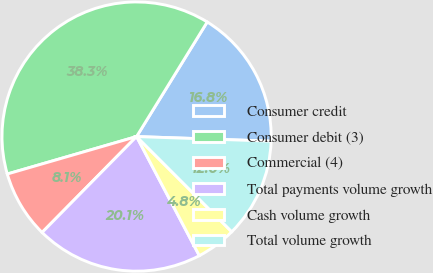Convert chart. <chart><loc_0><loc_0><loc_500><loc_500><pie_chart><fcel>Consumer credit<fcel>Consumer debit (3)<fcel>Commercial (4)<fcel>Total payments volume growth<fcel>Cash volume growth<fcel>Total volume growth<nl><fcel>16.75%<fcel>38.28%<fcel>8.13%<fcel>20.1%<fcel>4.78%<fcel>11.96%<nl></chart> 